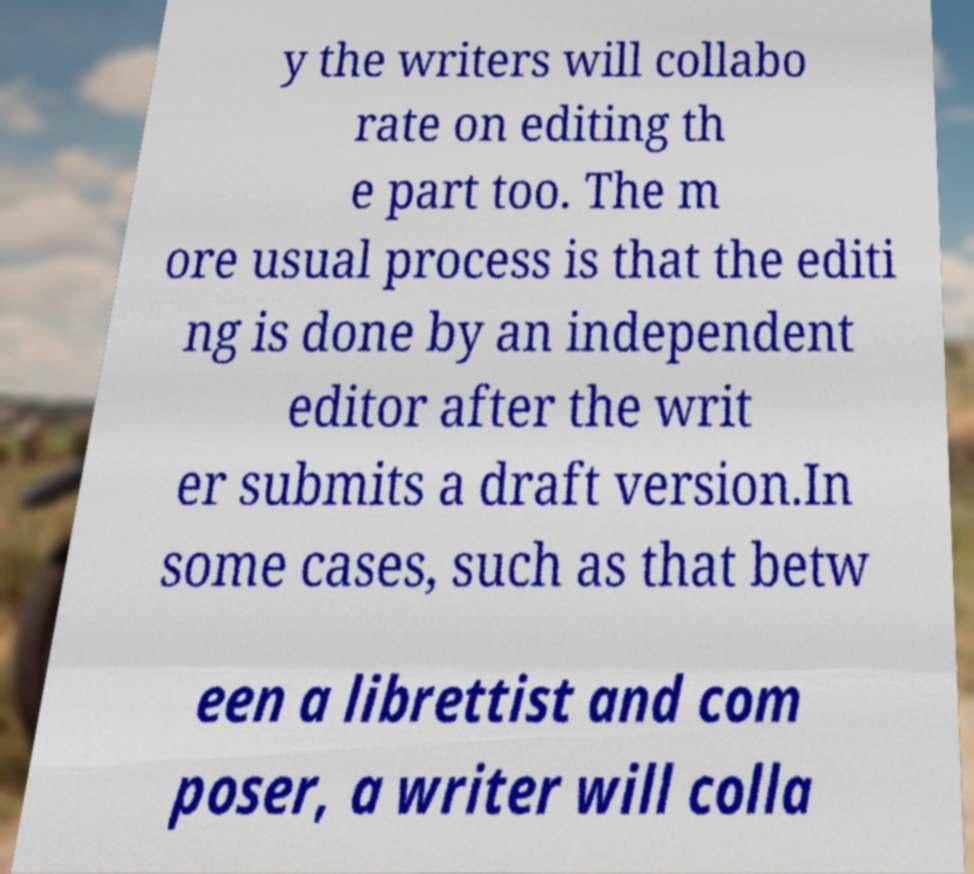Can you read and provide the text displayed in the image?This photo seems to have some interesting text. Can you extract and type it out for me? y the writers will collabo rate on editing th e part too. The m ore usual process is that the editi ng is done by an independent editor after the writ er submits a draft version.In some cases, such as that betw een a librettist and com poser, a writer will colla 